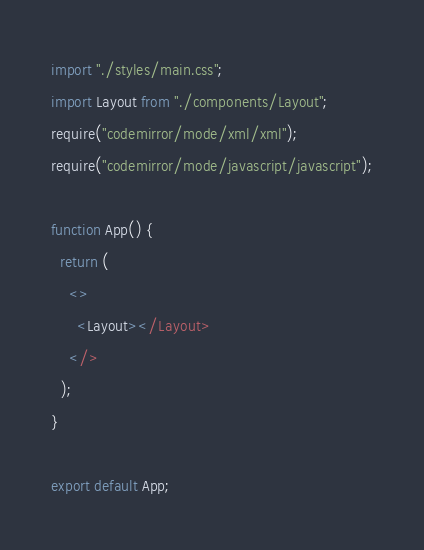<code> <loc_0><loc_0><loc_500><loc_500><_JavaScript_>import "./styles/main.css";
import Layout from "./components/Layout";
require("codemirror/mode/xml/xml");
require("codemirror/mode/javascript/javascript");

function App() {
  return (
    <>
      <Layout></Layout>
    </>
  );
}

export default App;
</code> 